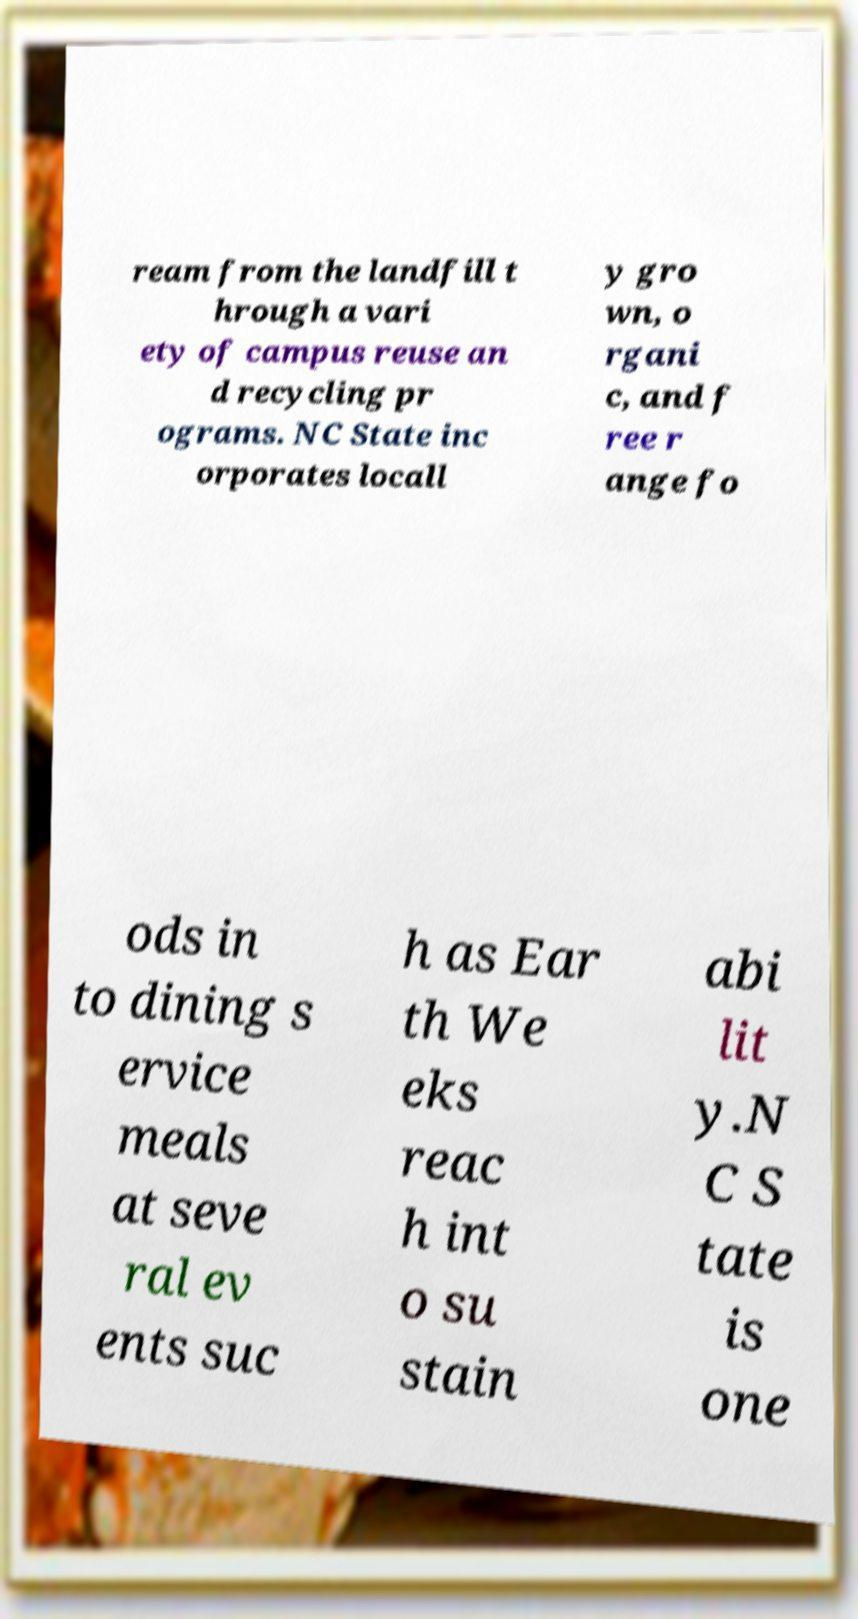Can you accurately transcribe the text from the provided image for me? ream from the landfill t hrough a vari ety of campus reuse an d recycling pr ograms. NC State inc orporates locall y gro wn, o rgani c, and f ree r ange fo ods in to dining s ervice meals at seve ral ev ents suc h as Ear th We eks reac h int o su stain abi lit y.N C S tate is one 